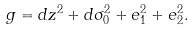Convert formula to latex. <formula><loc_0><loc_0><loc_500><loc_500>g = d z ^ { 2 } + d \sigma _ { 0 } ^ { 2 } + e _ { 1 } ^ { 2 } + e _ { 2 } ^ { 2 } .</formula> 